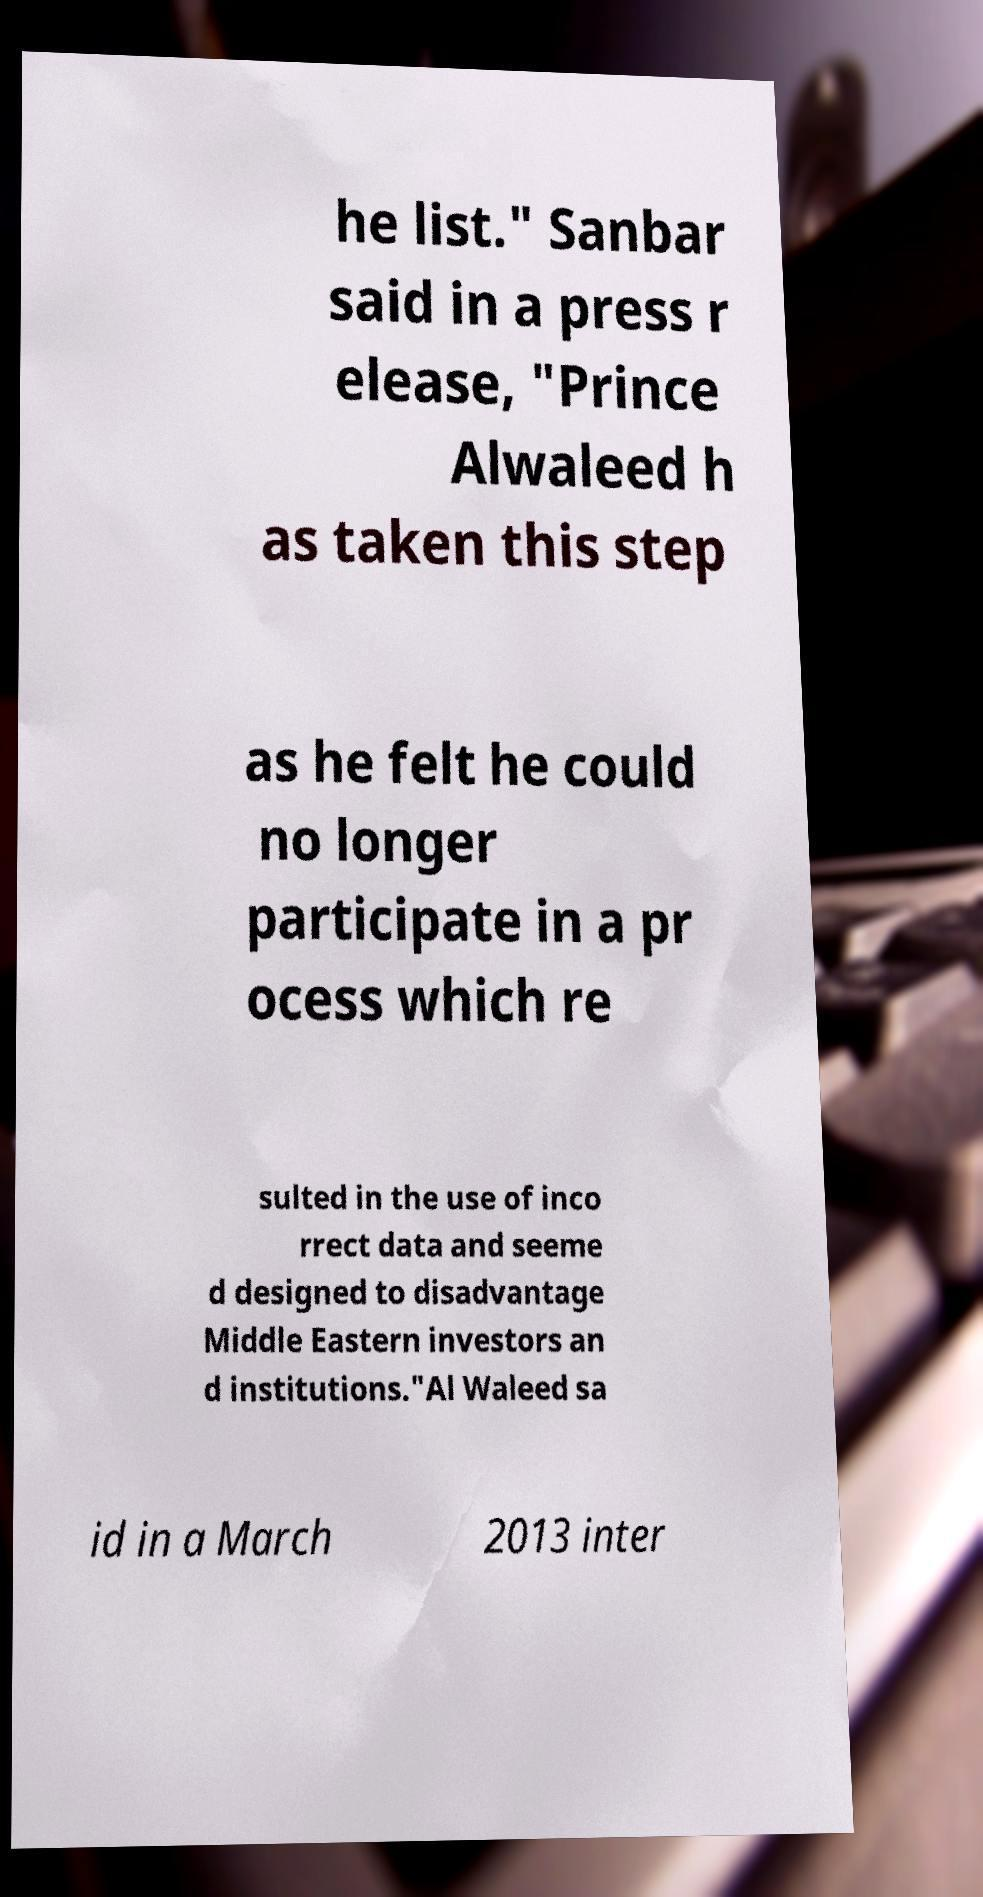Can you accurately transcribe the text from the provided image for me? he list." Sanbar said in a press r elease, "Prince Alwaleed h as taken this step as he felt he could no longer participate in a pr ocess which re sulted in the use of inco rrect data and seeme d designed to disadvantage Middle Eastern investors an d institutions."Al Waleed sa id in a March 2013 inter 